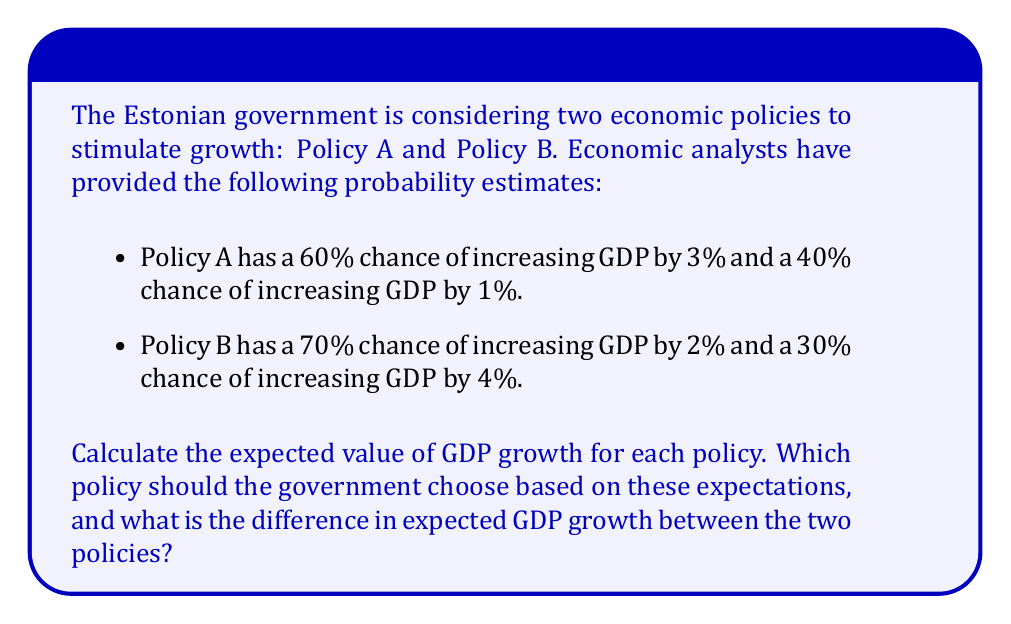Give your solution to this math problem. To solve this problem, we need to calculate the expected value of GDP growth for each policy using probability theory. The expected value is the sum of each possible outcome multiplied by its probability.

For Policy A:
$$E(A) = 0.60 \times 3\% + 0.40 \times 1\%$$
$$E(A) = 1.80\% + 0.40\% = 2.20\%$$

For Policy B:
$$E(B) = 0.70 \times 2\% + 0.30 \times 4\%$$
$$E(B) = 1.40\% + 1.20\% = 2.60\%$$

To determine which policy the government should choose, we compare the expected values:

Policy B has a higher expected GDP growth (2.60%) compared to Policy A (2.20%).

To calculate the difference in expected GDP growth:
$$\text{Difference} = E(B) - E(A) = 2.60\% - 2.20\% = 0.40\%$$

Therefore, based on these expectations, the government should choose Policy B, as it has a higher expected GDP growth. The difference in expected GDP growth between the two policies is 0.40 percentage points.
Answer: The government should choose Policy B. The difference in expected GDP growth between Policy B and Policy A is 0.40 percentage points. 